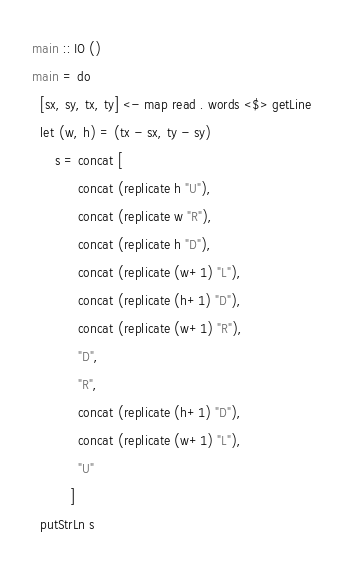Convert code to text. <code><loc_0><loc_0><loc_500><loc_500><_Haskell_>main :: IO ()
main = do
  [sx, sy, tx, ty] <- map read . words <$> getLine
  let (w, h) = (tx - sx, ty - sy)
      s = concat [
            concat (replicate h "U"),
            concat (replicate w "R"),
            concat (replicate h "D"),
            concat (replicate (w+1) "L"),
            concat (replicate (h+1) "D"),
            concat (replicate (w+1) "R"),
            "D",
            "R",
            concat (replicate (h+1) "D"),
            concat (replicate (w+1) "L"),
            "U"
          ]
  putStrLn s</code> 